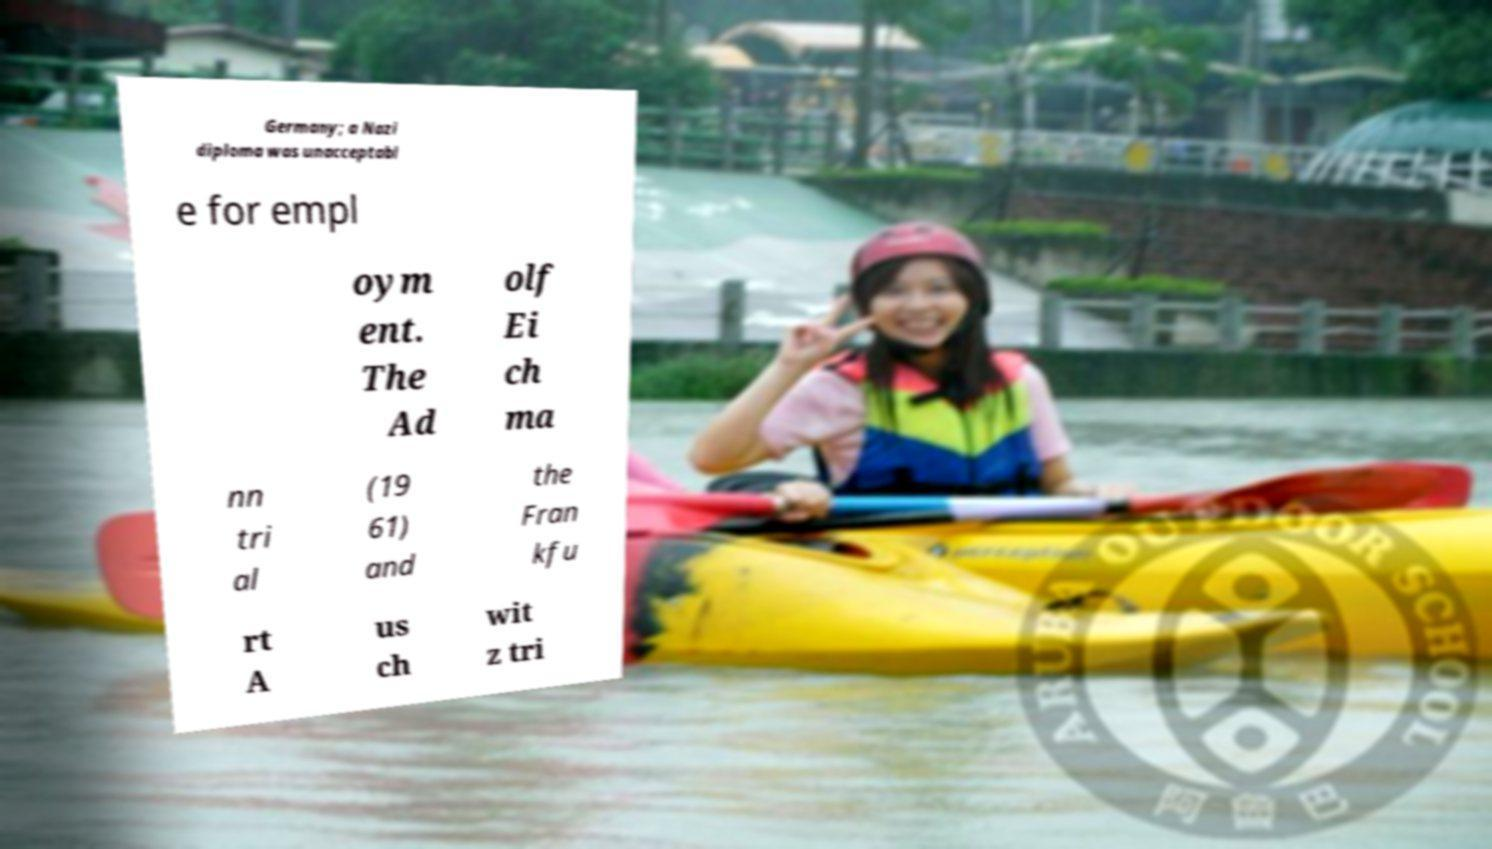Can you read and provide the text displayed in the image?This photo seems to have some interesting text. Can you extract and type it out for me? Germany; a Nazi diploma was unacceptabl e for empl oym ent. The Ad olf Ei ch ma nn tri al (19 61) and the Fran kfu rt A us ch wit z tri 